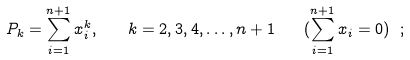<formula> <loc_0><loc_0><loc_500><loc_500>P _ { k } = \sum _ { i = 1 } ^ { n + 1 } x _ { i } ^ { k } , \quad k = 2 , 3 , 4 , \dots , n + 1 \quad ( \sum _ { i = 1 } ^ { n + 1 } x _ { i } = 0 ) \ ;</formula> 